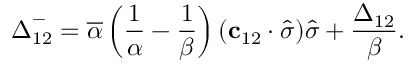<formula> <loc_0><loc_0><loc_500><loc_500>\Delta _ { 1 2 } ^ { - } = \overline { \alpha } \left ( \frac { 1 } { \alpha } - \frac { 1 } { \beta } \right ) ( c _ { 1 2 } \cdot \widehat { \sigma } ) \widehat { \sigma } + \frac { \Delta _ { 1 2 } } { \beta } .</formula> 